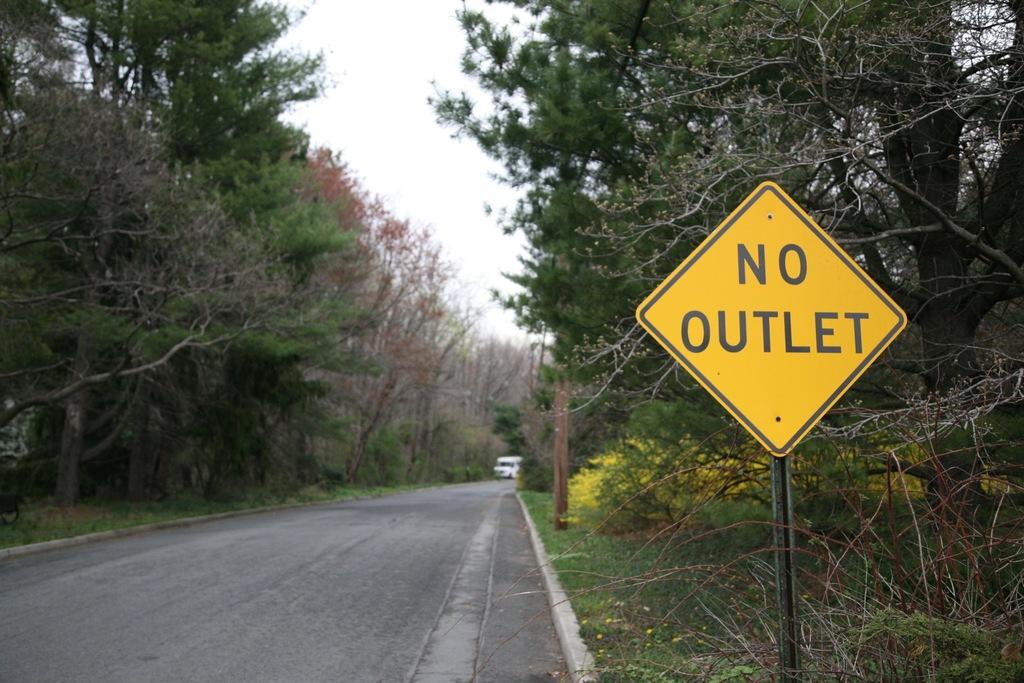What is the sign warning about?
Your response must be concise. No outlet. 